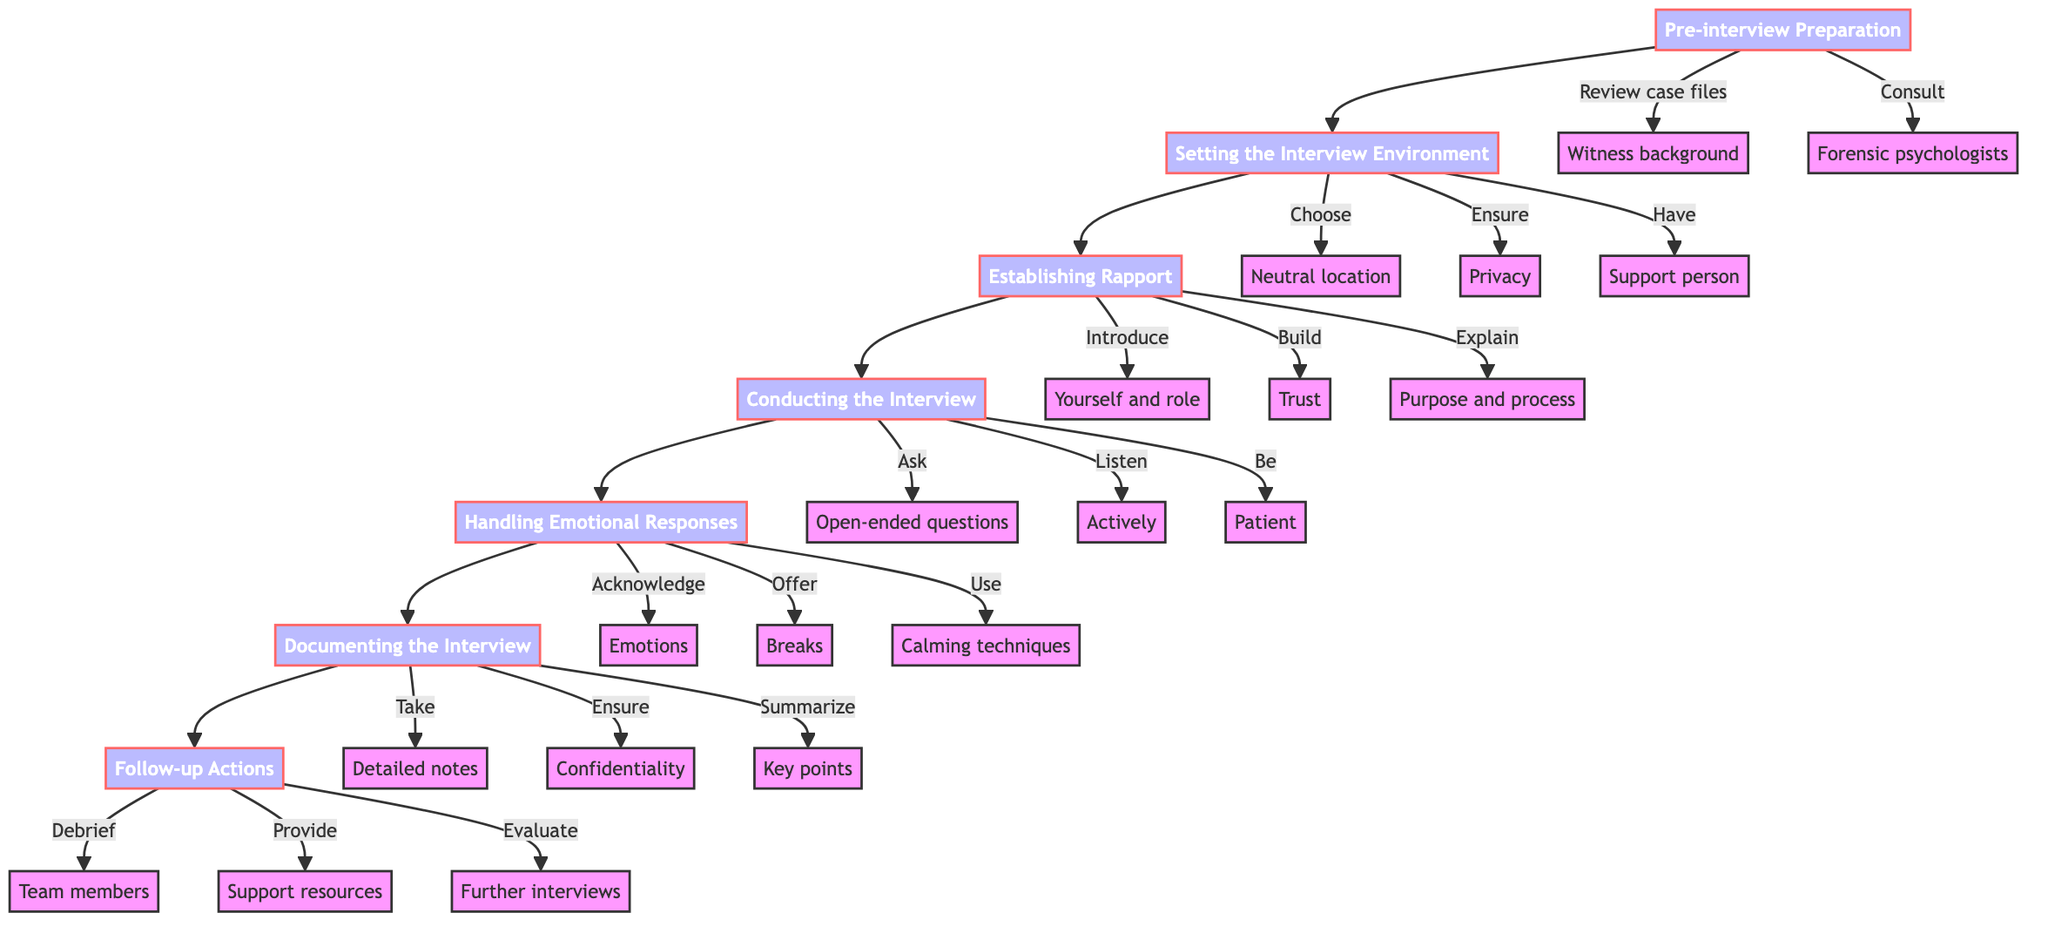What is the first step in the process? The first step as indicated in the diagram is "Pre-interview Preparation." This is the starting point before any other actions are taken.
Answer: Pre-interview Preparation How many main steps are there in the interview process? By counting the nodes in the flowchart, we can identify that there are seven main steps outlined in the process, indicating a structured approach to the interviews.
Answer: 7 What action is taken after "Establishing Rapport"? Following "Establishing Rapport," the next action is "Conducting the Interview." This shows the progression from building trust to actively engaging with the witness.
Answer: Conducting the Interview What are the three actions listed under "Handling Emotional Responses"? The three actions listed under this node are "Acknowledge and validate emotions," "Offer breaks if needed," and "Use calming techniques as advised by psychologists." They highlight the approach to managing emotional reactions during the interview.
Answer: Acknowledge and validate emotions, Offer breaks if needed, Use calming techniques as advised by psychologists What types of questions should be asked during "Conducting the Interview"? According to the diagram, the questions that should be asked are "Open-ended questions." This indicates the interviewer's aim to encourage detailed responses rather than simple yes or no answers.
Answer: Open-ended questions What is one of the actions under "Follow-up Actions"? One of the actions under this step is "Debrief with team members." This reflects the importance of collaboration and communication after the interview to ensure everyone is aligned.
Answer: Debrief with team members Which step requires consultation with forensic psychologists? The step that involves consulting with forensic psychologists is "Pre-interview Preparation." This is crucial for setting the right approach in handling sensitive witness interviews.
Answer: Pre-interview Preparation What is the main purpose of "Documenting the Interview"? The main purpose of "Documenting the Interview" is to accurately record the witness's statements and ensure confidentiality of the recorded materials. This is vital for maintaining the integrity of the interview process.
Answer: To accurately record statements and ensure confidentiality 